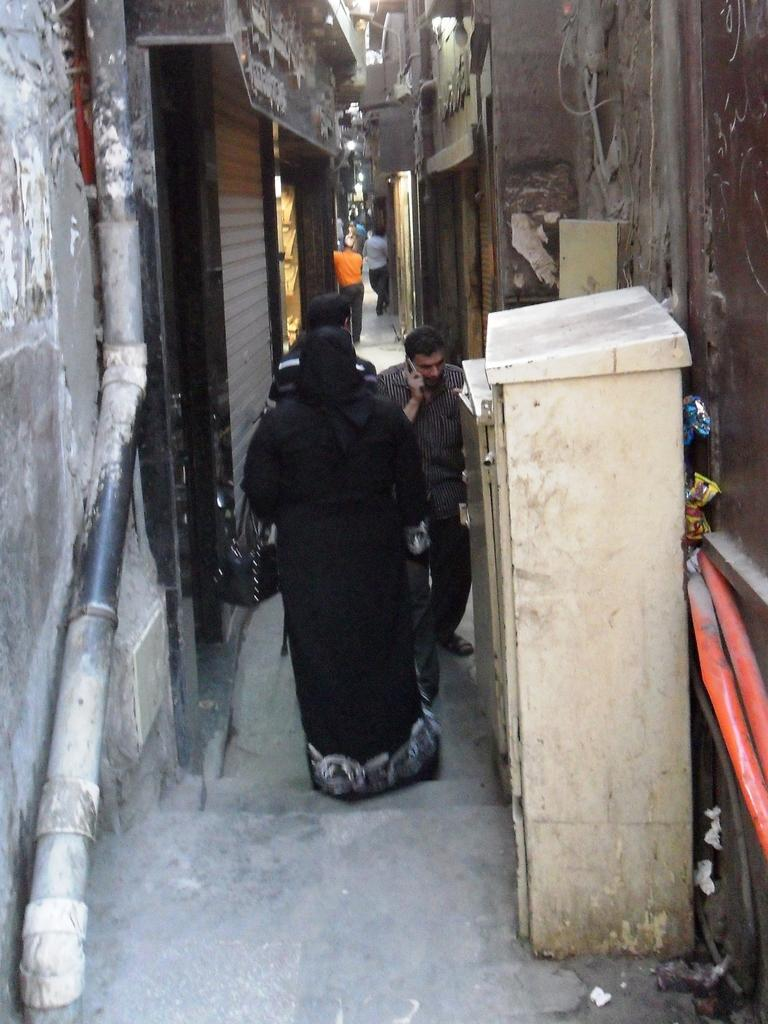What is in the foreground of the image? In the foreground of the image, there is a building wall, a pipe, and a cupboard. What is happening on the road in the image? There is a group of people on the road in the image. What time of day was the image taken? The image was taken during the day. What type of doctor can be seen treating a rabbit in the image? There is no doctor or rabbit present in the image. What unit of measurement is used to determine the size of the pipe in the image? The size of the pipe is not mentioned in the image, so it is not possible to determine the unit of measurement used. 